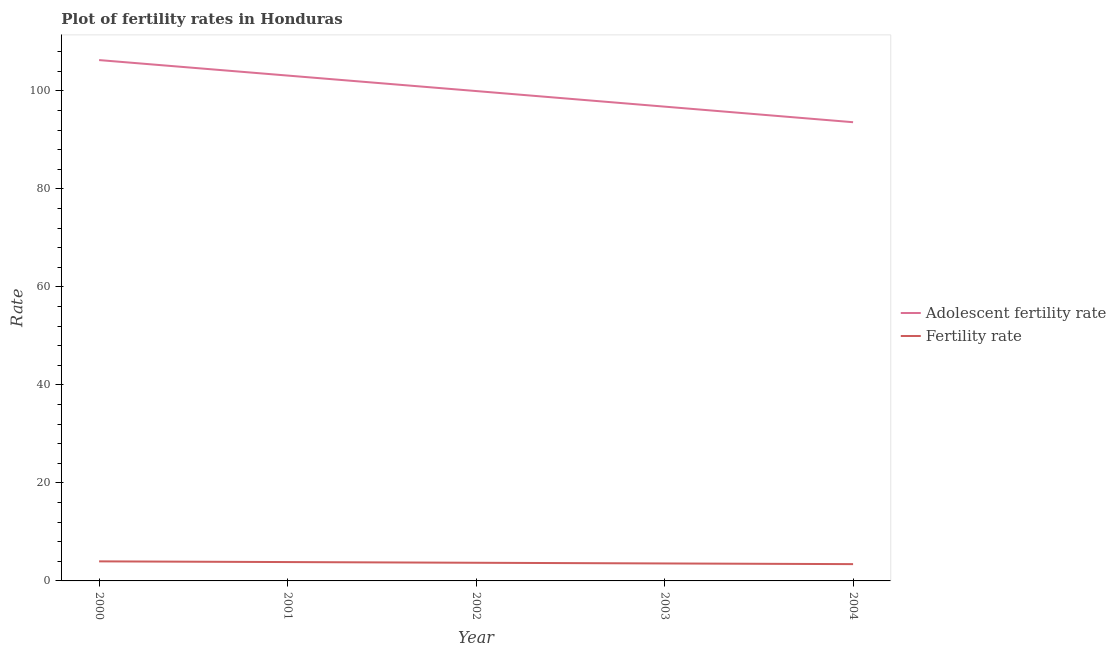Does the line corresponding to fertility rate intersect with the line corresponding to adolescent fertility rate?
Your response must be concise. No. What is the fertility rate in 2001?
Your answer should be compact. 3.85. Across all years, what is the maximum fertility rate?
Keep it short and to the point. 3.99. Across all years, what is the minimum adolescent fertility rate?
Provide a short and direct response. 93.6. In which year was the adolescent fertility rate minimum?
Make the answer very short. 2004. What is the total adolescent fertility rate in the graph?
Offer a very short reply. 499.74. What is the difference between the fertility rate in 2000 and that in 2004?
Give a very brief answer. 0.57. What is the difference between the fertility rate in 2003 and the adolescent fertility rate in 2002?
Provide a succinct answer. -96.4. What is the average adolescent fertility rate per year?
Your answer should be very brief. 99.95. In the year 2004, what is the difference between the fertility rate and adolescent fertility rate?
Offer a very short reply. -90.17. In how many years, is the adolescent fertility rate greater than 8?
Your response must be concise. 5. What is the ratio of the adolescent fertility rate in 2002 to that in 2003?
Ensure brevity in your answer.  1.03. What is the difference between the highest and the second highest adolescent fertility rate?
Make the answer very short. 3.16. What is the difference between the highest and the lowest adolescent fertility rate?
Your answer should be compact. 12.68. Is the adolescent fertility rate strictly greater than the fertility rate over the years?
Provide a succinct answer. Yes. Is the adolescent fertility rate strictly less than the fertility rate over the years?
Offer a terse response. No. How many lines are there?
Make the answer very short. 2. How many years are there in the graph?
Give a very brief answer. 5. What is the difference between two consecutive major ticks on the Y-axis?
Keep it short and to the point. 20. Does the graph contain any zero values?
Make the answer very short. No. Does the graph contain grids?
Provide a succinct answer. No. Where does the legend appear in the graph?
Your answer should be compact. Center right. How many legend labels are there?
Your answer should be compact. 2. What is the title of the graph?
Ensure brevity in your answer.  Plot of fertility rates in Honduras. Does "Food and tobacco" appear as one of the legend labels in the graph?
Your answer should be very brief. No. What is the label or title of the X-axis?
Offer a terse response. Year. What is the label or title of the Y-axis?
Your response must be concise. Rate. What is the Rate of Adolescent fertility rate in 2000?
Offer a very short reply. 106.28. What is the Rate in Fertility rate in 2000?
Your answer should be very brief. 3.99. What is the Rate in Adolescent fertility rate in 2001?
Provide a short and direct response. 103.12. What is the Rate of Fertility rate in 2001?
Give a very brief answer. 3.85. What is the Rate of Adolescent fertility rate in 2002?
Provide a short and direct response. 99.96. What is the Rate in Fertility rate in 2002?
Offer a very short reply. 3.71. What is the Rate in Adolescent fertility rate in 2003?
Your response must be concise. 96.78. What is the Rate of Fertility rate in 2003?
Offer a very short reply. 3.56. What is the Rate in Adolescent fertility rate in 2004?
Provide a succinct answer. 93.6. What is the Rate of Fertility rate in 2004?
Offer a terse response. 3.43. Across all years, what is the maximum Rate of Adolescent fertility rate?
Give a very brief answer. 106.28. Across all years, what is the maximum Rate in Fertility rate?
Keep it short and to the point. 3.99. Across all years, what is the minimum Rate in Adolescent fertility rate?
Offer a terse response. 93.6. Across all years, what is the minimum Rate of Fertility rate?
Give a very brief answer. 3.43. What is the total Rate of Adolescent fertility rate in the graph?
Ensure brevity in your answer.  499.74. What is the total Rate of Fertility rate in the graph?
Your response must be concise. 18.54. What is the difference between the Rate in Adolescent fertility rate in 2000 and that in 2001?
Your answer should be compact. 3.16. What is the difference between the Rate in Fertility rate in 2000 and that in 2001?
Your response must be concise. 0.14. What is the difference between the Rate of Adolescent fertility rate in 2000 and that in 2002?
Your answer should be compact. 6.32. What is the difference between the Rate of Fertility rate in 2000 and that in 2002?
Offer a terse response. 0.29. What is the difference between the Rate of Adolescent fertility rate in 2000 and that in 2003?
Give a very brief answer. 9.5. What is the difference between the Rate in Fertility rate in 2000 and that in 2003?
Provide a short and direct response. 0.43. What is the difference between the Rate of Adolescent fertility rate in 2000 and that in 2004?
Your response must be concise. 12.68. What is the difference between the Rate in Fertility rate in 2000 and that in 2004?
Give a very brief answer. 0.57. What is the difference between the Rate of Adolescent fertility rate in 2001 and that in 2002?
Offer a very short reply. 3.16. What is the difference between the Rate in Fertility rate in 2001 and that in 2002?
Provide a short and direct response. 0.14. What is the difference between the Rate in Adolescent fertility rate in 2001 and that in 2003?
Your answer should be very brief. 6.34. What is the difference between the Rate of Fertility rate in 2001 and that in 2003?
Provide a succinct answer. 0.28. What is the difference between the Rate of Adolescent fertility rate in 2001 and that in 2004?
Make the answer very short. 9.52. What is the difference between the Rate in Fertility rate in 2001 and that in 2004?
Provide a short and direct response. 0.42. What is the difference between the Rate in Adolescent fertility rate in 2002 and that in 2003?
Give a very brief answer. 3.18. What is the difference between the Rate of Fertility rate in 2002 and that in 2003?
Give a very brief answer. 0.14. What is the difference between the Rate of Adolescent fertility rate in 2002 and that in 2004?
Keep it short and to the point. 6.36. What is the difference between the Rate of Fertility rate in 2002 and that in 2004?
Your answer should be very brief. 0.28. What is the difference between the Rate in Adolescent fertility rate in 2003 and that in 2004?
Provide a succinct answer. 3.18. What is the difference between the Rate in Fertility rate in 2003 and that in 2004?
Keep it short and to the point. 0.14. What is the difference between the Rate in Adolescent fertility rate in 2000 and the Rate in Fertility rate in 2001?
Offer a very short reply. 102.43. What is the difference between the Rate in Adolescent fertility rate in 2000 and the Rate in Fertility rate in 2002?
Make the answer very short. 102.57. What is the difference between the Rate of Adolescent fertility rate in 2000 and the Rate of Fertility rate in 2003?
Make the answer very short. 102.72. What is the difference between the Rate in Adolescent fertility rate in 2000 and the Rate in Fertility rate in 2004?
Keep it short and to the point. 102.85. What is the difference between the Rate of Adolescent fertility rate in 2001 and the Rate of Fertility rate in 2002?
Provide a short and direct response. 99.41. What is the difference between the Rate of Adolescent fertility rate in 2001 and the Rate of Fertility rate in 2003?
Ensure brevity in your answer.  99.56. What is the difference between the Rate of Adolescent fertility rate in 2001 and the Rate of Fertility rate in 2004?
Ensure brevity in your answer.  99.69. What is the difference between the Rate of Adolescent fertility rate in 2002 and the Rate of Fertility rate in 2003?
Provide a succinct answer. 96.4. What is the difference between the Rate in Adolescent fertility rate in 2002 and the Rate in Fertility rate in 2004?
Ensure brevity in your answer.  96.53. What is the difference between the Rate of Adolescent fertility rate in 2003 and the Rate of Fertility rate in 2004?
Ensure brevity in your answer.  93.35. What is the average Rate of Adolescent fertility rate per year?
Your answer should be compact. 99.95. What is the average Rate in Fertility rate per year?
Offer a terse response. 3.71. In the year 2000, what is the difference between the Rate in Adolescent fertility rate and Rate in Fertility rate?
Keep it short and to the point. 102.29. In the year 2001, what is the difference between the Rate of Adolescent fertility rate and Rate of Fertility rate?
Your answer should be compact. 99.27. In the year 2002, what is the difference between the Rate in Adolescent fertility rate and Rate in Fertility rate?
Ensure brevity in your answer.  96.25. In the year 2003, what is the difference between the Rate in Adolescent fertility rate and Rate in Fertility rate?
Make the answer very short. 93.22. In the year 2004, what is the difference between the Rate in Adolescent fertility rate and Rate in Fertility rate?
Offer a very short reply. 90.17. What is the ratio of the Rate of Adolescent fertility rate in 2000 to that in 2001?
Your response must be concise. 1.03. What is the ratio of the Rate in Fertility rate in 2000 to that in 2001?
Provide a short and direct response. 1.04. What is the ratio of the Rate of Adolescent fertility rate in 2000 to that in 2002?
Your answer should be compact. 1.06. What is the ratio of the Rate in Fertility rate in 2000 to that in 2002?
Your response must be concise. 1.08. What is the ratio of the Rate in Adolescent fertility rate in 2000 to that in 2003?
Make the answer very short. 1.1. What is the ratio of the Rate in Fertility rate in 2000 to that in 2003?
Your answer should be compact. 1.12. What is the ratio of the Rate in Adolescent fertility rate in 2000 to that in 2004?
Offer a terse response. 1.14. What is the ratio of the Rate of Fertility rate in 2000 to that in 2004?
Your response must be concise. 1.17. What is the ratio of the Rate of Adolescent fertility rate in 2001 to that in 2002?
Offer a very short reply. 1.03. What is the ratio of the Rate in Fertility rate in 2001 to that in 2002?
Give a very brief answer. 1.04. What is the ratio of the Rate of Adolescent fertility rate in 2001 to that in 2003?
Give a very brief answer. 1.07. What is the ratio of the Rate in Fertility rate in 2001 to that in 2003?
Provide a short and direct response. 1.08. What is the ratio of the Rate in Adolescent fertility rate in 2001 to that in 2004?
Give a very brief answer. 1.1. What is the ratio of the Rate of Fertility rate in 2001 to that in 2004?
Provide a succinct answer. 1.12. What is the ratio of the Rate of Adolescent fertility rate in 2002 to that in 2003?
Your response must be concise. 1.03. What is the ratio of the Rate of Fertility rate in 2002 to that in 2003?
Provide a short and direct response. 1.04. What is the ratio of the Rate in Adolescent fertility rate in 2002 to that in 2004?
Provide a succinct answer. 1.07. What is the ratio of the Rate of Fertility rate in 2002 to that in 2004?
Provide a succinct answer. 1.08. What is the ratio of the Rate in Adolescent fertility rate in 2003 to that in 2004?
Provide a succinct answer. 1.03. What is the ratio of the Rate in Fertility rate in 2003 to that in 2004?
Provide a succinct answer. 1.04. What is the difference between the highest and the second highest Rate of Adolescent fertility rate?
Offer a very short reply. 3.16. What is the difference between the highest and the second highest Rate of Fertility rate?
Offer a very short reply. 0.14. What is the difference between the highest and the lowest Rate in Adolescent fertility rate?
Your answer should be very brief. 12.68. What is the difference between the highest and the lowest Rate of Fertility rate?
Make the answer very short. 0.57. 